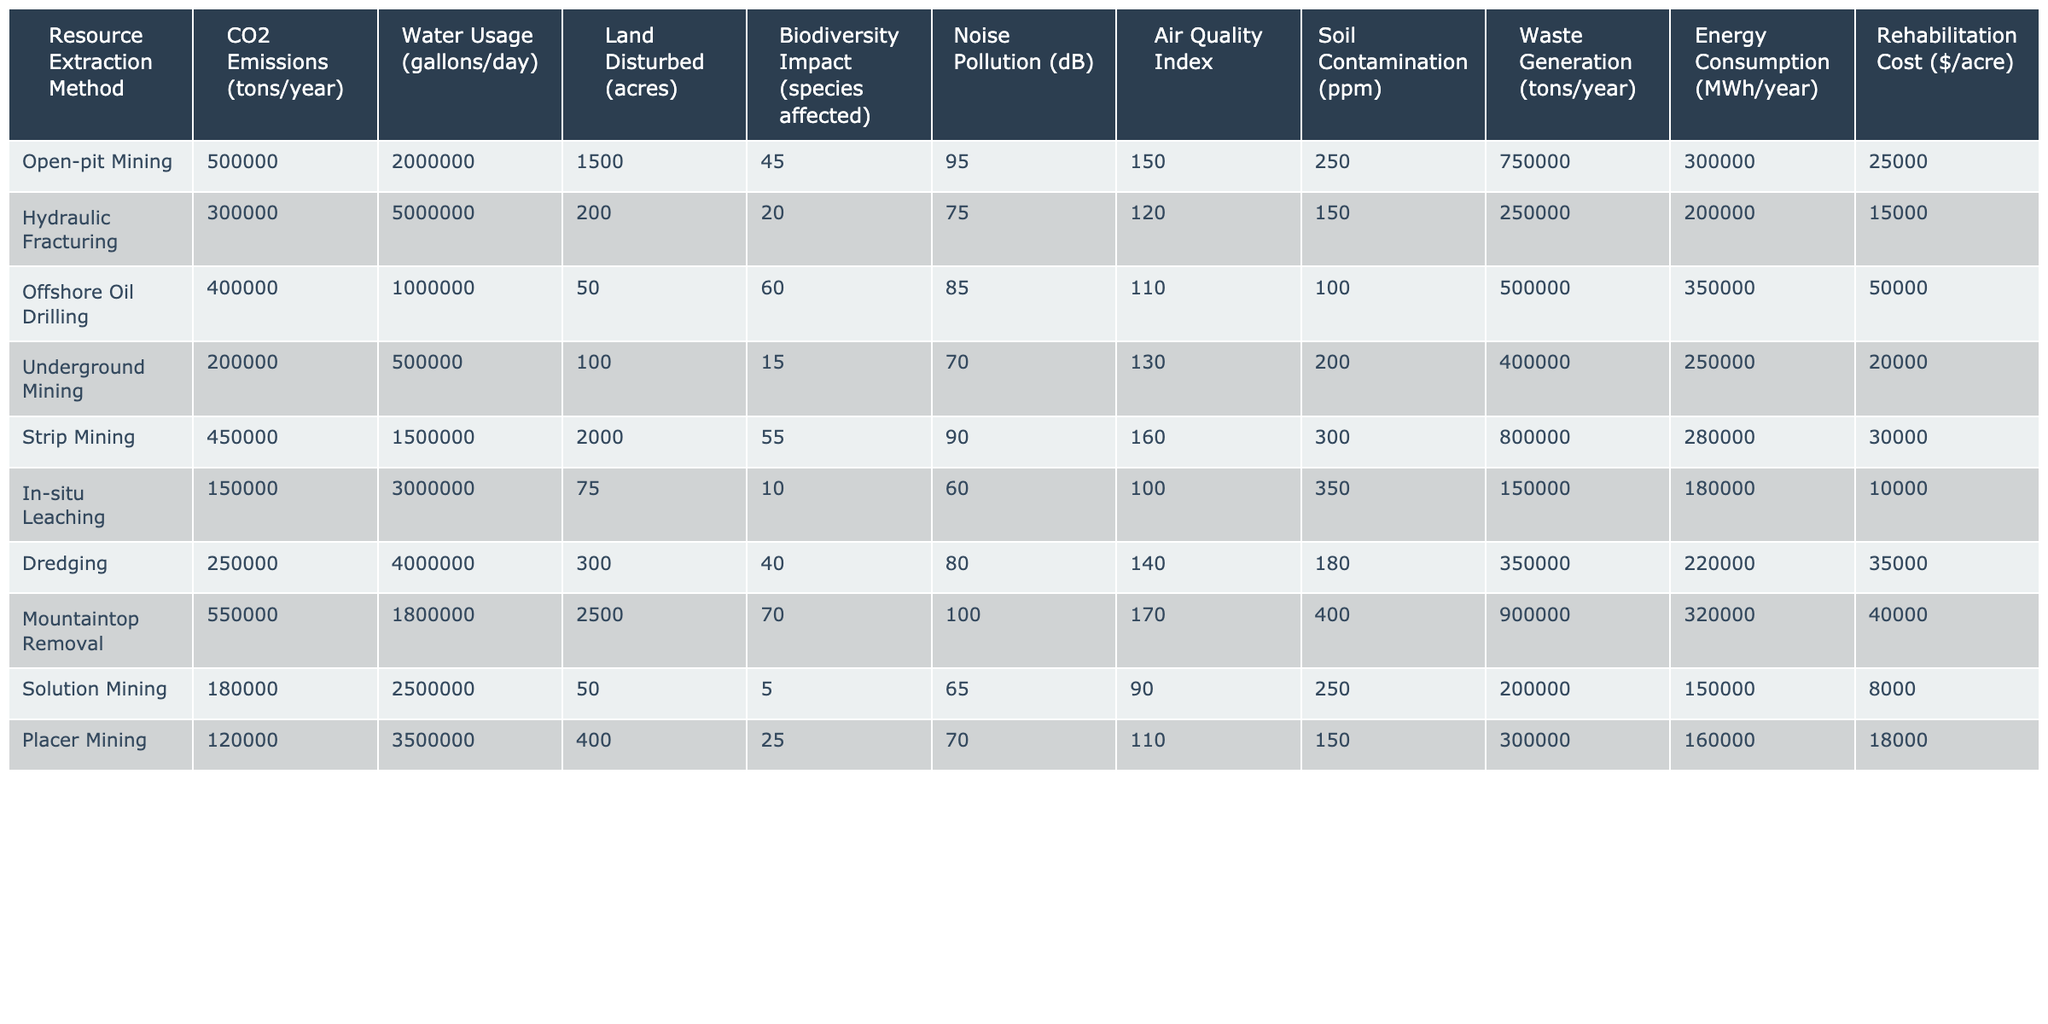What is the highest CO2 emissions among the resource extraction methods? By looking at the CO2 Emissions column in the table, the highest value is found for Mountaintop Removal, which has 550,000 tons/year.
Answer: 550,000 tons/year Which resource extraction method uses the least amount of water? Scanning the Water Usage column, In-situ Leaching uses the least amount at 3,000,000 gallons/day.
Answer: 3,000,000 gallons/day How many acres are disturbed by Open-pit Mining? The Land Disturbed column indicates that Open-pit Mining disturbs 1,500 acres.
Answer: 1,500 acres What is the total noise pollution in dB from Strip Mining and Underground Mining? Adding the Noise Pollution values for both Strip Mining (90 dB) and Underground Mining (70 dB) gives us 90 + 70 = 160 dB.
Answer: 160 dB Is the Air Quality Index higher for Offshore Oil Drilling than for Hydraulic Fracturing? Comparing the Air Quality Index values, Offshore Oil Drilling is 110 and Hydraulic Fracturing is 120. Since 110 is less than 120, the answer is no.
Answer: No What is the average soil contamination across all resource extraction methods? To find the average, we add all Soil Contamination values (250 + 150 + 100 + 200 + 300 + 350 + 180 + 400 + 250 + 150) = 2,330, and then divide by the number of methods (10) to get 2,330 / 10 = 233.
Answer: 233 ppm Is there a method with less than 20 species affected in its biodiversity impact? Checking the Biodiversity Impact column, In-situ Leaching has only 10 species affected, which is less than 20, confirming that this is true.
Answer: Yes Which resource extraction method has the highest rehabilitation cost per acre? By examining the Rehabilitation Cost column, Mountaintop Removal has the highest cost at $40,000 per acre.
Answer: $40,000 per acre What is the difference in waste generation between Hydraulic Fracturing and Off-shore Oil Drilling? The Waste Generation for Hydraulic Fracturing is 250,000 tons/year and for Offshore Oil Drilling it is 500,000 tons/year. The difference is 500,000 - 250,000 = 250,000 tons/year.
Answer: 250,000 tons/year What is the total energy consumption for both Placer Mining and Dredging combined? Looking at the Energy Consumption column, Placer Mining consumes 160,000 MWh/year and Dredging consumes 220,000 MWh/year. The total is 160,000 + 220,000 = 380,000 MWh/year.
Answer: 380,000 MWh/year 